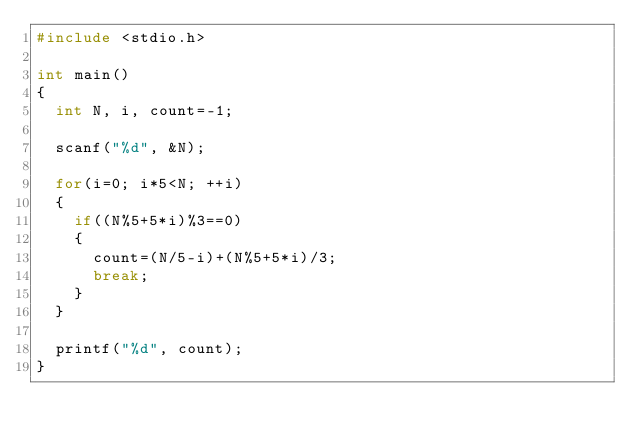Convert code to text. <code><loc_0><loc_0><loc_500><loc_500><_C_>#include <stdio.h>

int main()
{
	int N, i, count=-1;

	scanf("%d", &N);

	for(i=0; i*5<N; ++i)
	{
		if((N%5+5*i)%3==0)
		{
			count=(N/5-i)+(N%5+5*i)/3;
			break;
		}
	}

	printf("%d", count);
}
</code> 